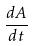Convert formula to latex. <formula><loc_0><loc_0><loc_500><loc_500>\frac { d A } { d t }</formula> 